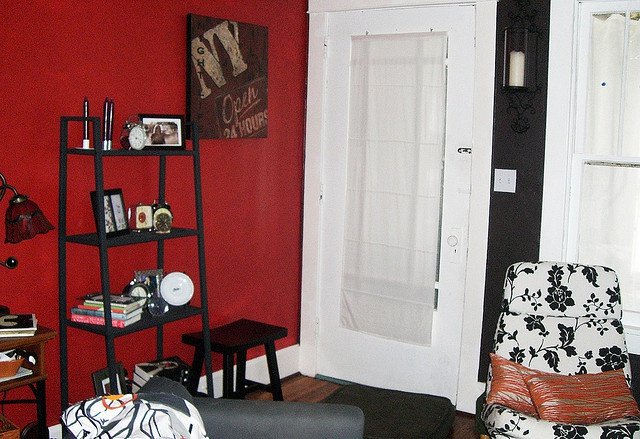Describe the objects in this image and their specific colors. I can see chair in maroon, lightgray, black, gray, and darkgray tones, couch in maroon, gray, black, and purple tones, book in maroon, black, gray, darkgray, and olive tones, clock in maroon, black, lightgray, and darkgray tones, and book in maroon, black, gray, and white tones in this image. 